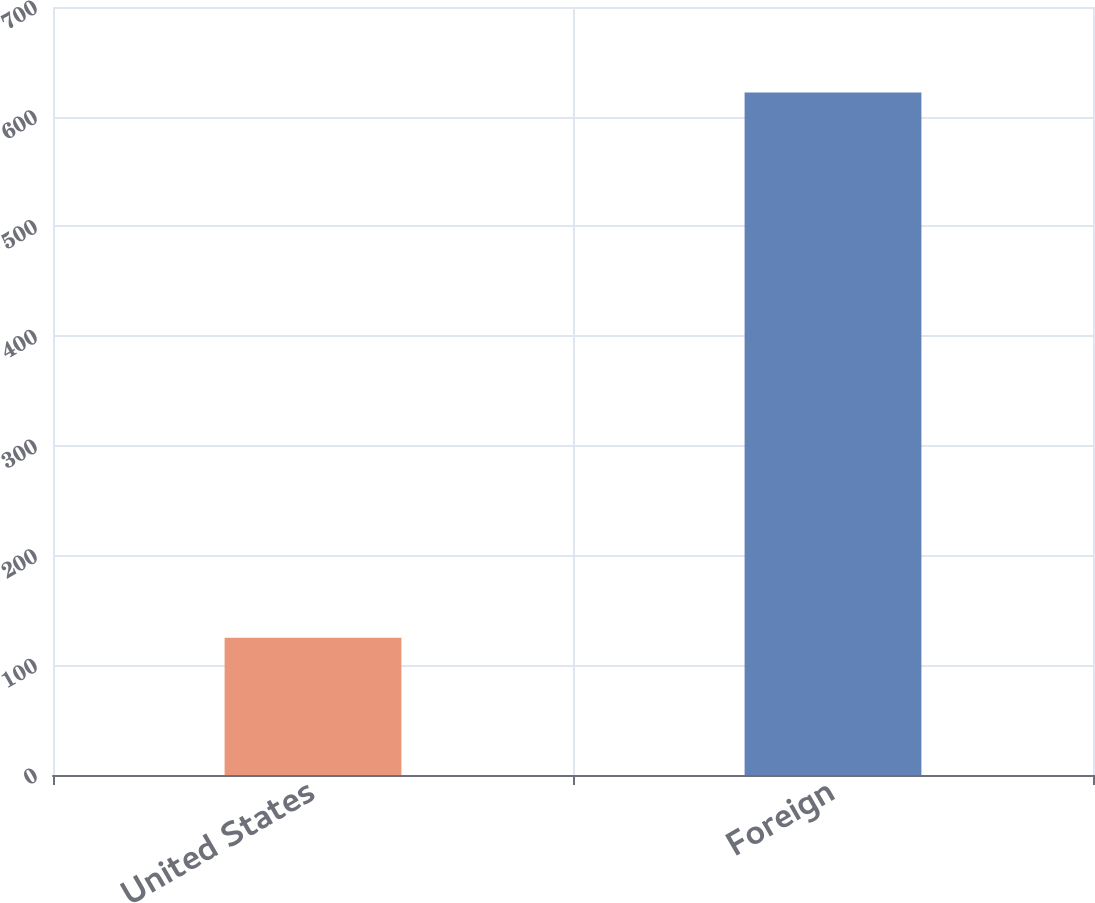<chart> <loc_0><loc_0><loc_500><loc_500><bar_chart><fcel>United States<fcel>Foreign<nl><fcel>125<fcel>622<nl></chart> 